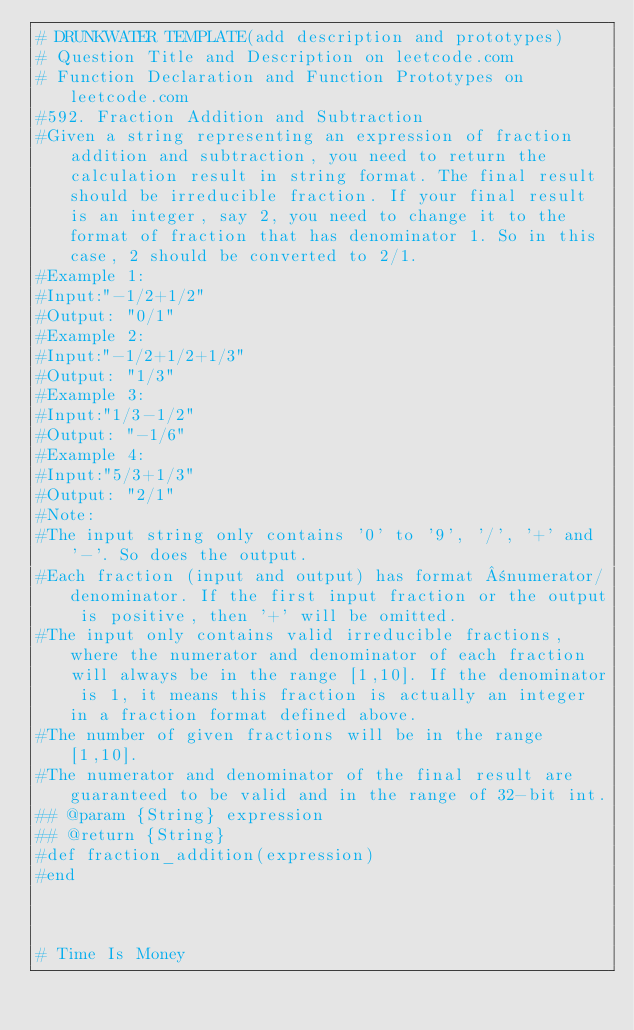Convert code to text. <code><loc_0><loc_0><loc_500><loc_500><_Ruby_># DRUNKWATER TEMPLATE(add description and prototypes)
# Question Title and Description on leetcode.com
# Function Declaration and Function Prototypes on leetcode.com
#592. Fraction Addition and Subtraction
#Given a string representing an expression of fraction addition and subtraction, you need to return the calculation result in string format. The final result should be irreducible fraction. If your final result is an integer, say 2, you need to change it to the format of fraction that has denominator 1. So in this case, 2 should be converted to 2/1.
#Example 1:
#Input:"-1/2+1/2"
#Output: "0/1"
#Example 2:
#Input:"-1/2+1/2+1/3"
#Output: "1/3"
#Example 3:
#Input:"1/3-1/2"
#Output: "-1/6"
#Example 4:
#Input:"5/3+1/3"
#Output: "2/1"
#Note:
#The input string only contains '0' to '9', '/', '+' and '-'. So does the output.
#Each fraction (input and output) has format ±numerator/denominator. If the first input fraction or the output is positive, then '+' will be omitted.
#The input only contains valid irreducible fractions, where the numerator and denominator of each fraction will always be in the range [1,10]. If the denominator is 1, it means this fraction is actually an integer in a fraction format defined above.
#The number of given fractions will be in the range [1,10].
#The numerator and denominator of the final result are guaranteed to be valid and in the range of 32-bit int.
## @param {String} expression
## @return {String}
#def fraction_addition(expression)
#end



# Time Is Money</code> 